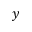Convert formula to latex. <formula><loc_0><loc_0><loc_500><loc_500>y</formula> 